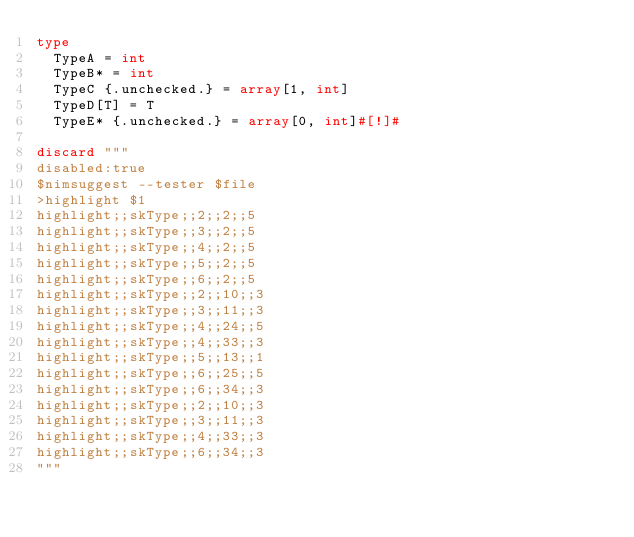Convert code to text. <code><loc_0><loc_0><loc_500><loc_500><_Nim_>type
  TypeA = int
  TypeB* = int
  TypeC {.unchecked.} = array[1, int]
  TypeD[T] = T
  TypeE* {.unchecked.} = array[0, int]#[!]#

discard """
disabled:true
$nimsuggest --tester $file
>highlight $1
highlight;;skType;;2;;2;;5
highlight;;skType;;3;;2;;5
highlight;;skType;;4;;2;;5
highlight;;skType;;5;;2;;5
highlight;;skType;;6;;2;;5
highlight;;skType;;2;;10;;3
highlight;;skType;;3;;11;;3
highlight;;skType;;4;;24;;5
highlight;;skType;;4;;33;;3
highlight;;skType;;5;;13;;1
highlight;;skType;;6;;25;;5
highlight;;skType;;6;;34;;3
highlight;;skType;;2;;10;;3
highlight;;skType;;3;;11;;3
highlight;;skType;;4;;33;;3
highlight;;skType;;6;;34;;3
"""
</code> 